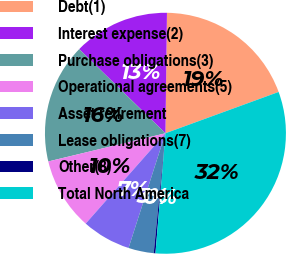<chart> <loc_0><loc_0><loc_500><loc_500><pie_chart><fcel>Debt(1)<fcel>Interest expense(2)<fcel>Purchase obligations(3)<fcel>Operational agreements(5)<fcel>Asset retirement<fcel>Lease obligations(7)<fcel>Other(8)<fcel>Total North America<nl><fcel>19.23%<fcel>12.9%<fcel>16.06%<fcel>9.73%<fcel>6.56%<fcel>3.4%<fcel>0.23%<fcel>31.89%<nl></chart> 